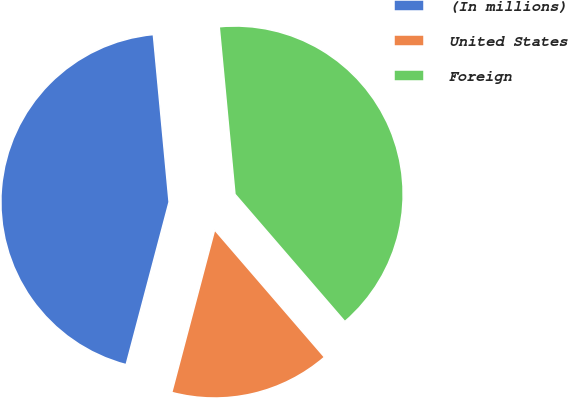Convert chart to OTSL. <chart><loc_0><loc_0><loc_500><loc_500><pie_chart><fcel>(In millions)<fcel>United States<fcel>Foreign<nl><fcel>44.4%<fcel>15.44%<fcel>40.16%<nl></chart> 